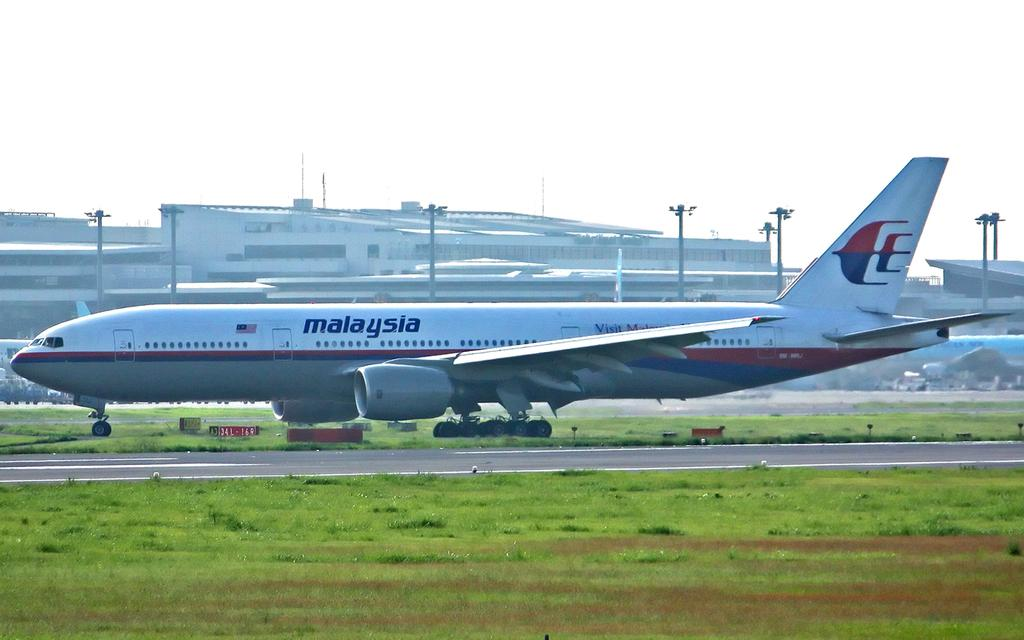Provide a one-sentence caption for the provided image. A Mayayisan airplane sits  on the grass beside a runway. 